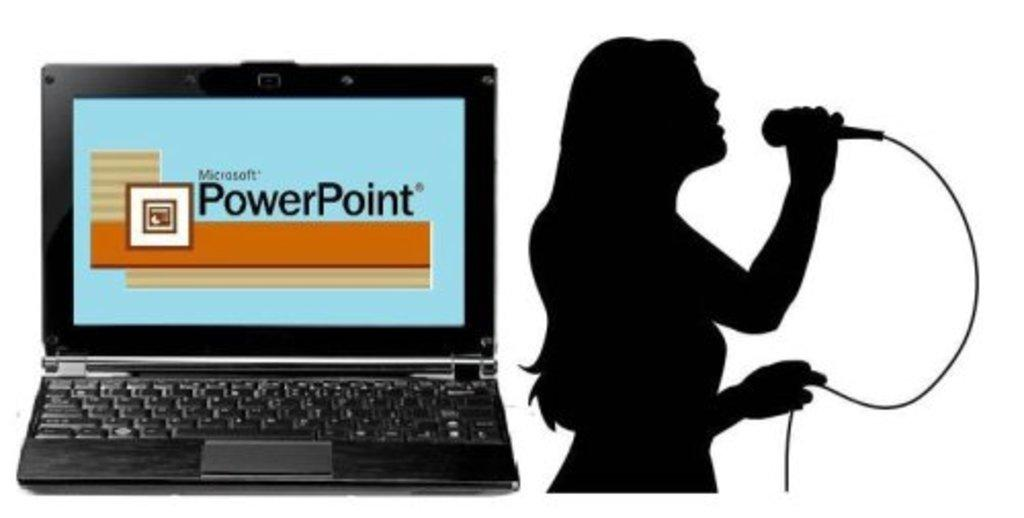Who is the main subject in the image? There is a woman in the image. What is the woman doing in the image? The woman is singing. What object is the woman holding while singing? The woman is holding a microphone. What electronic device can be seen in the image? There is a laptop in the image. What type of cherries can be seen growing on the grass in the image? There are no cherries or grass present in the image. 